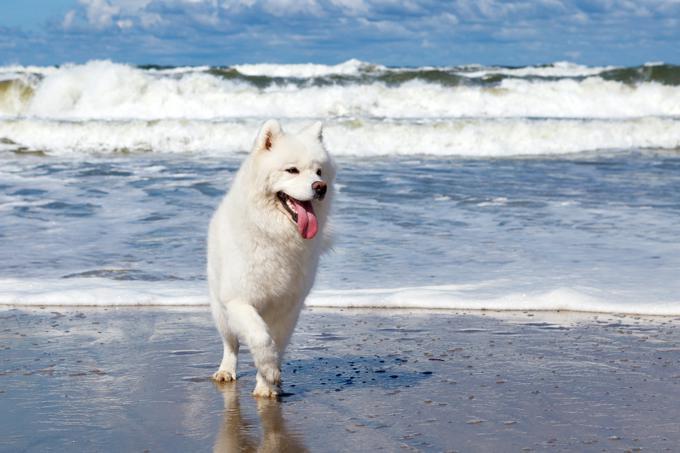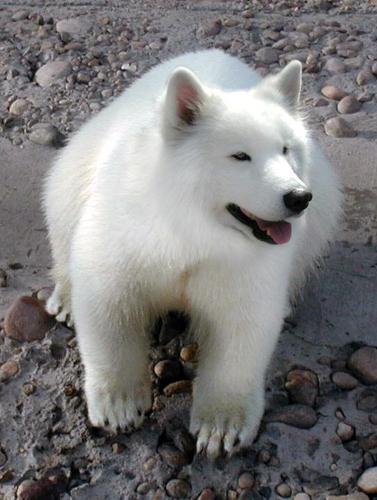The first image is the image on the left, the second image is the image on the right. For the images displayed, is the sentence "An image shows one white dog in an arctic-type frozen scene." factually correct? Answer yes or no. No. The first image is the image on the left, the second image is the image on the right. Analyze the images presented: Is the assertion "One of the images shows a dog in snow." valid? Answer yes or no. No. 